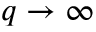<formula> <loc_0><loc_0><loc_500><loc_500>q \to \infty</formula> 